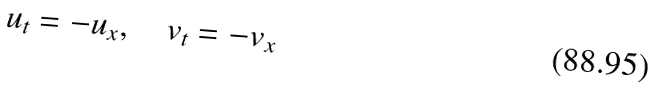<formula> <loc_0><loc_0><loc_500><loc_500>u _ { t } = - u _ { x } , \quad v _ { t } = - v _ { x }</formula> 